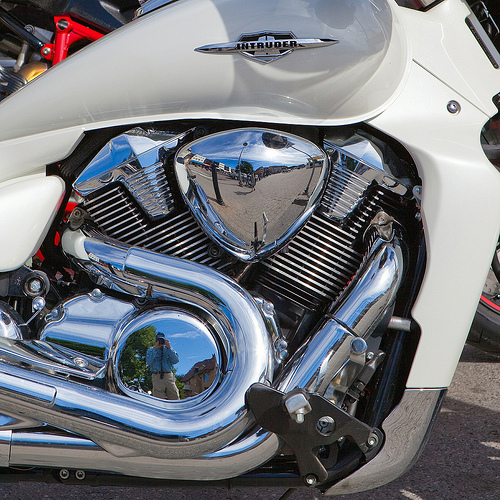<image>
Can you confirm if the concrete is behind the wheel? No. The concrete is not behind the wheel. From this viewpoint, the concrete appears to be positioned elsewhere in the scene. 